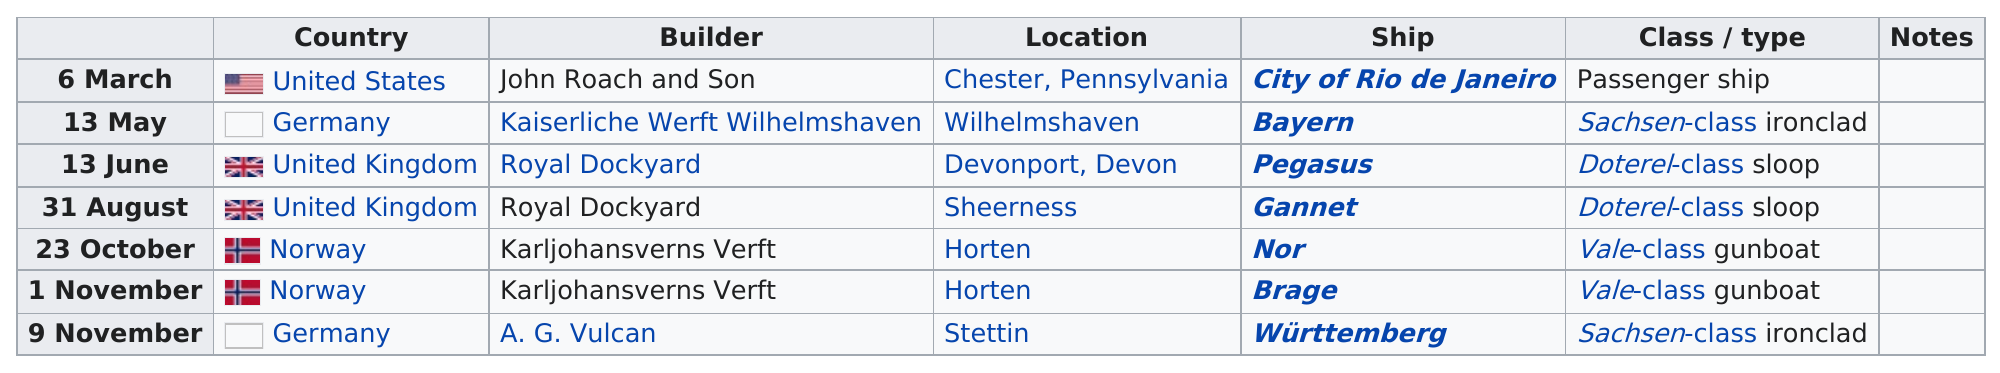Highlight a few significant elements in this photo. Determine the number of different types of ships launched. The result is four. The Brage boat had the same class as the Nor. The City of Rio de Janeiro was the first ship to be launched in 1878. The launches of Rio de Janeiro and Bayern were 68 days apart. The launch of the Pegasus was followed by the next ship, the Gannet. 